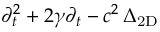Convert formula to latex. <formula><loc_0><loc_0><loc_500><loc_500>\partial _ { t } ^ { 2 } + 2 \gamma \partial _ { t } - c ^ { 2 } \, \Delta _ { 2 D }</formula> 